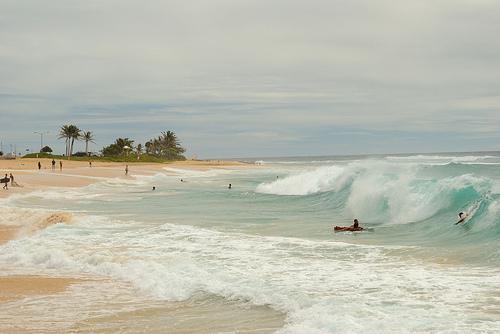How many people are in boats in the image?
Give a very brief answer. 1. 